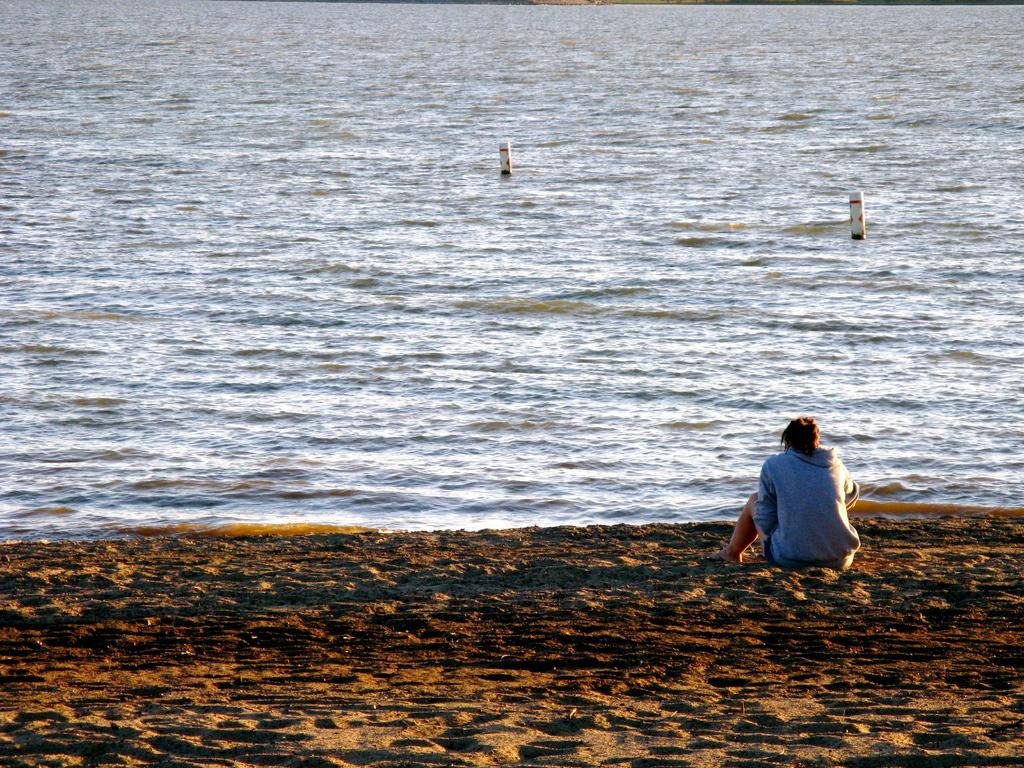What is the person in the image sitting on? The person is sitting on the sand. What can be seen in the background of the image? There are poles in the water in the background of the image. What type of linen is being used to cover the tray in the image? There is no tray or linen present in the image. 